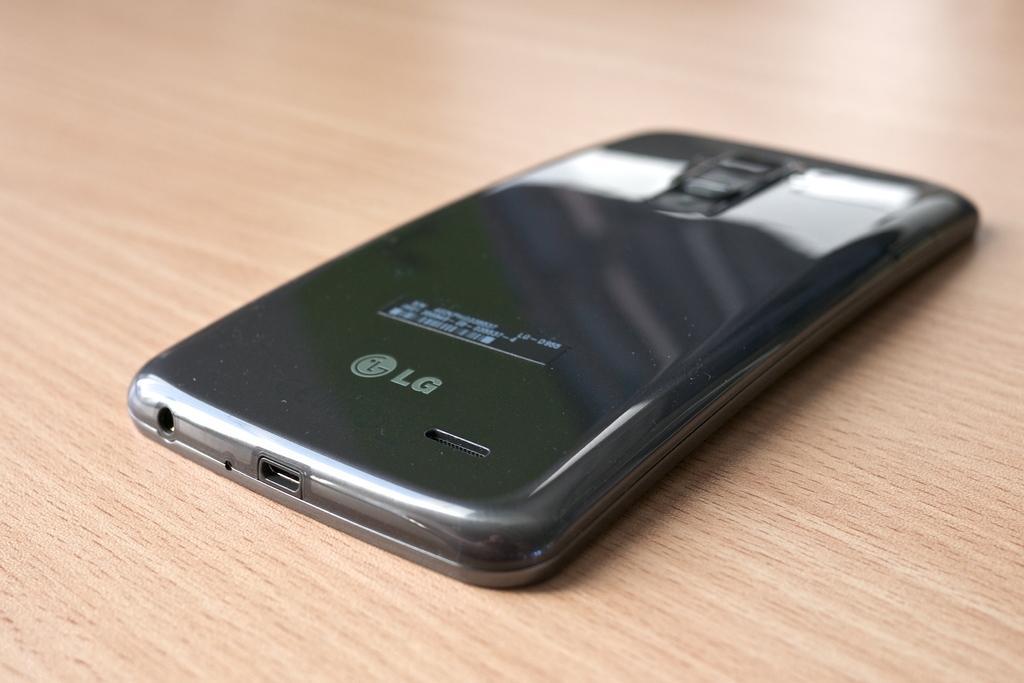Describe this image in one or two sentences. Here in this picture we can see a mobile phone present on the table over there. 